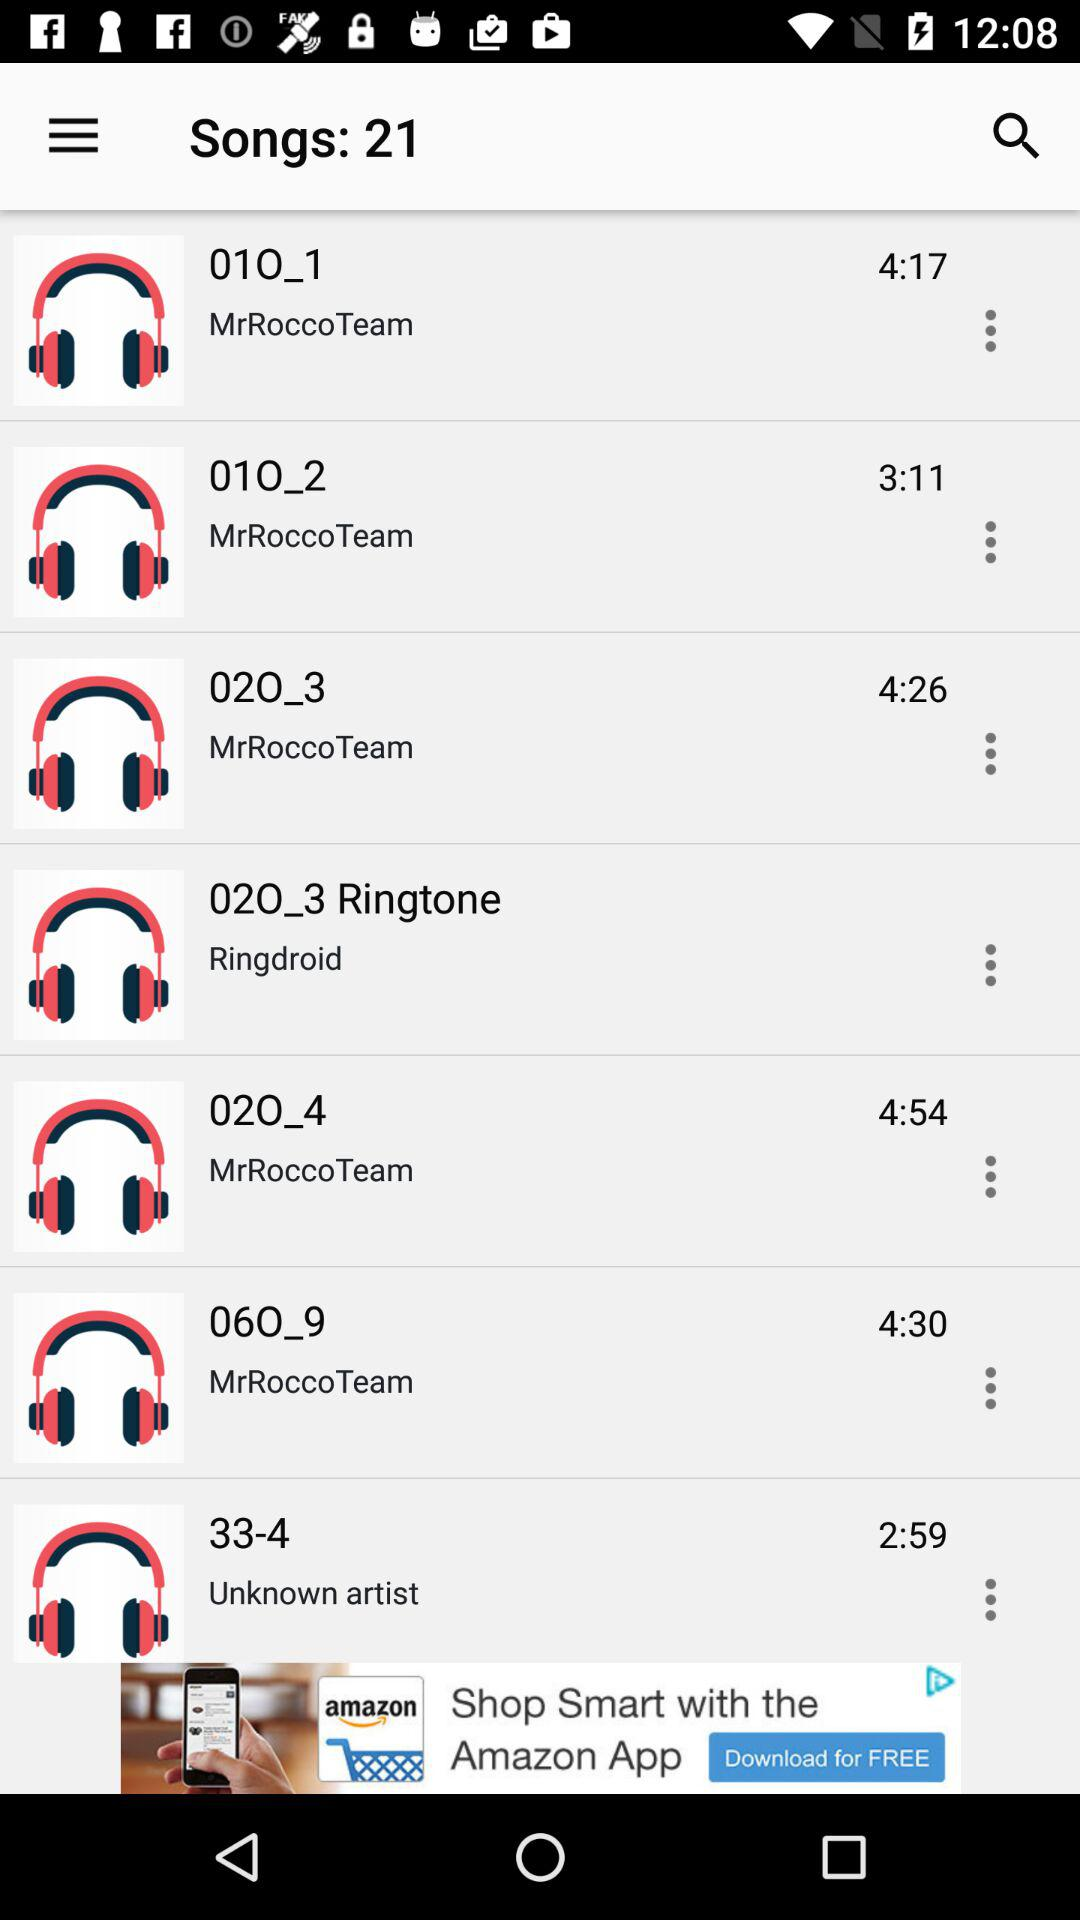What is the duration of "33-4"? The duration of "33-4" is 2 minutes and 59 seconds. 